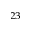Convert formula to latex. <formula><loc_0><loc_0><loc_500><loc_500>^ { 2 3 }</formula> 